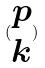<formula> <loc_0><loc_0><loc_500><loc_500>( \begin{matrix} p \\ k \end{matrix} )</formula> 